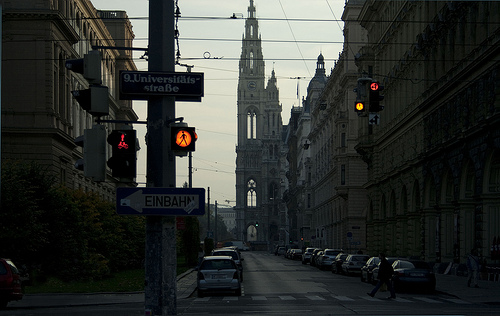What kind of mood does this image convey? The image conveys a calm and serene mood, underscored by the stillness of the scene, the quiet streets, and the soft, diffused natural light that gives the setting an almost ethereal quality. 